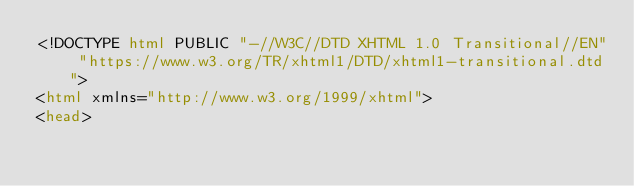<code> <loc_0><loc_0><loc_500><loc_500><_HTML_><!DOCTYPE html PUBLIC "-//W3C//DTD XHTML 1.0 Transitional//EN" "https://www.w3.org/TR/xhtml1/DTD/xhtml1-transitional.dtd">
<html xmlns="http://www.w3.org/1999/xhtml">
<head></code> 